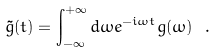Convert formula to latex. <formula><loc_0><loc_0><loc_500><loc_500>\tilde { g } ( t ) = \int ^ { + \infty } _ { - \infty } d \omega e ^ { - i \omega t } g ( \omega ) \ .</formula> 